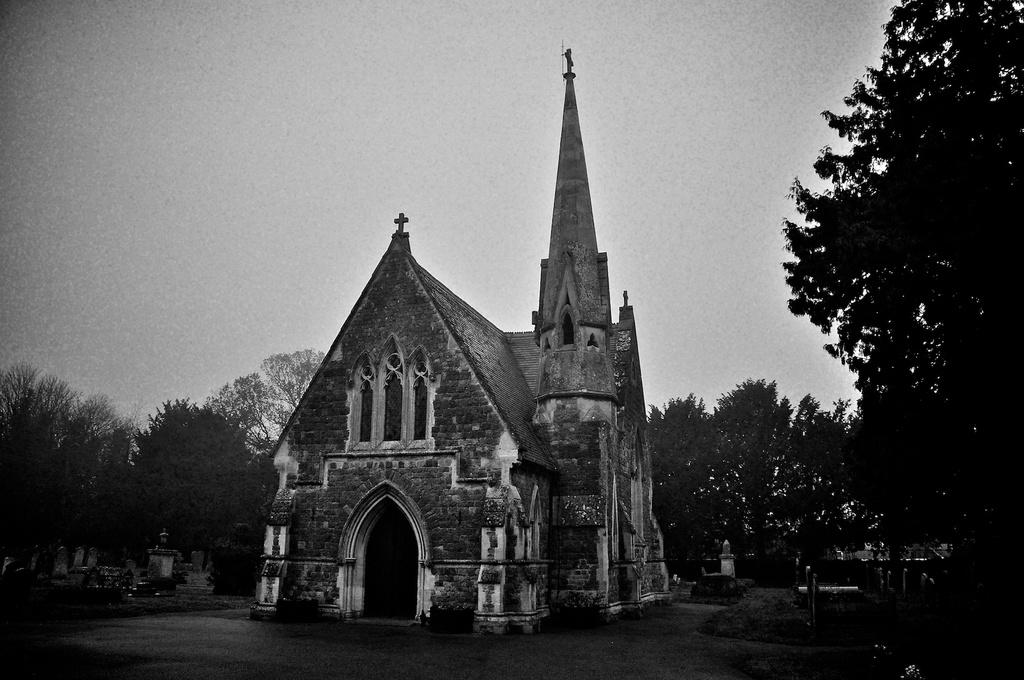What type of structure can be seen in the background of the image? There is a house in the background of the image. What type of vegetation is present in the image? There are trees in the image. What type of string is being used to hold the chicken in the image? There is no chicken or string present in the image. 